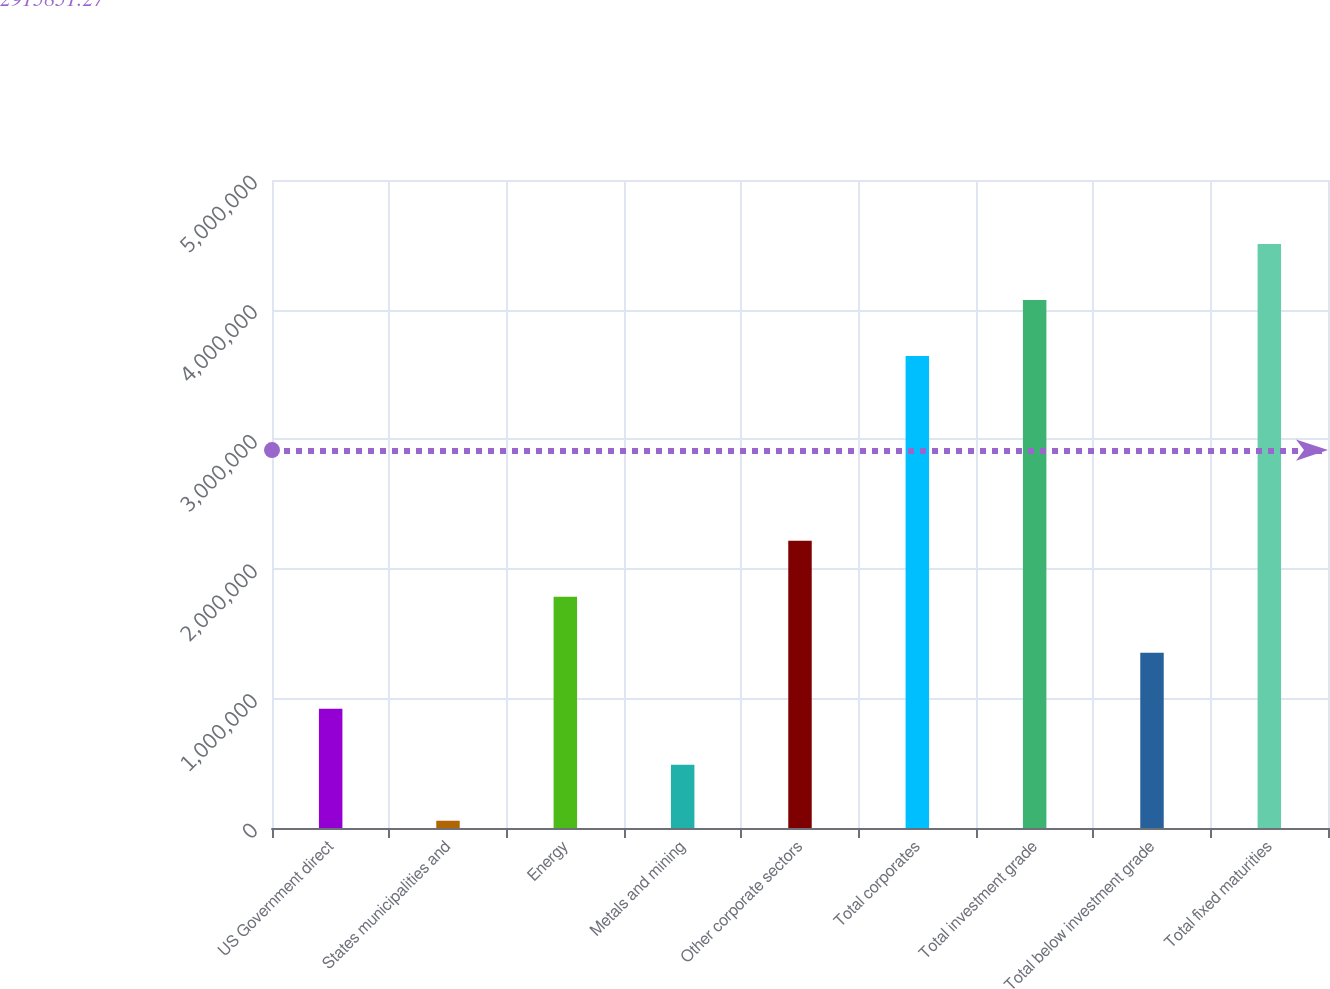<chart> <loc_0><loc_0><loc_500><loc_500><bar_chart><fcel>US Government direct<fcel>States municipalities and<fcel>Energy<fcel>Metals and mining<fcel>Other corporate sectors<fcel>Total corporates<fcel>Total investment grade<fcel>Total below investment grade<fcel>Total fixed maturities<nl><fcel>920299<fcel>56022<fcel>1.78458e+06<fcel>488161<fcel>2.21672e+06<fcel>3.64211e+06<fcel>4.07425e+06<fcel>1.35244e+06<fcel>4.50639e+06<nl></chart> 